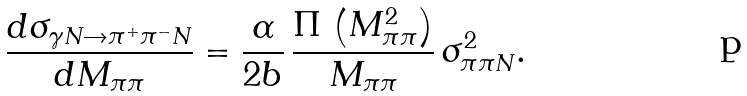<formula> <loc_0><loc_0><loc_500><loc_500>\frac { d \sigma _ { \gamma N \rightarrow \pi ^ { + } \pi ^ { - } N } } { d M _ { \pi \pi } } = \frac { \alpha } { 2 b } \, \frac { \Pi \, \left ( M _ { \pi \pi } ^ { 2 } \right ) } { M _ { \pi \pi } } \, \sigma _ { \pi \pi N } ^ { 2 } .</formula> 